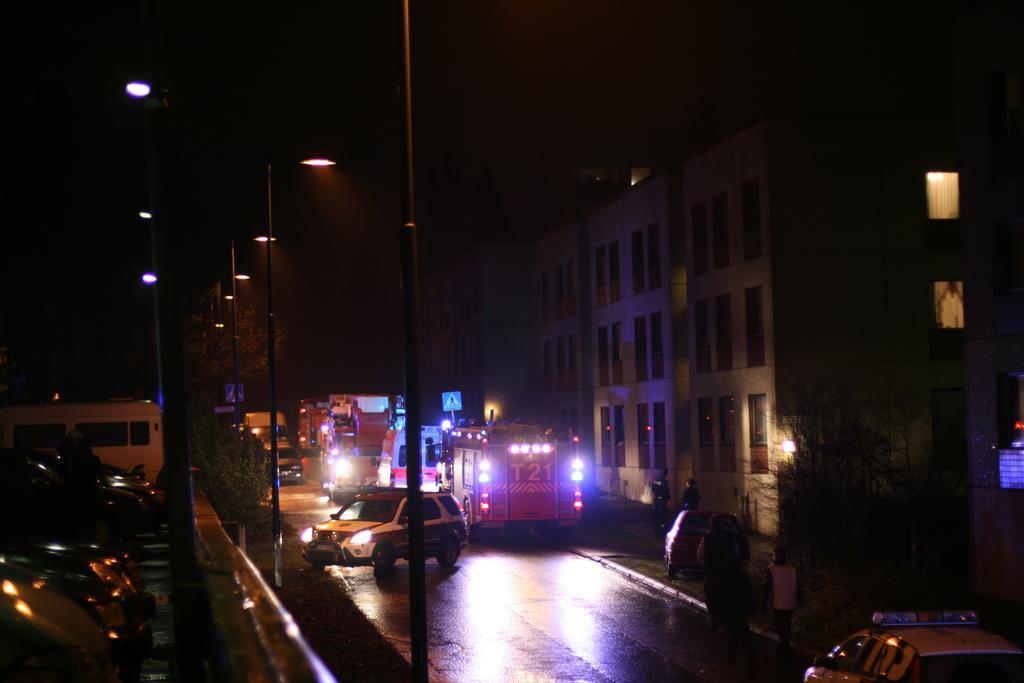Describe this image in one or two sentences. In this picture we can see buildings, vehicles, electric light poles, some persons, windows. At the bottom of the image there is a road. At the top of the image there is a sky. 